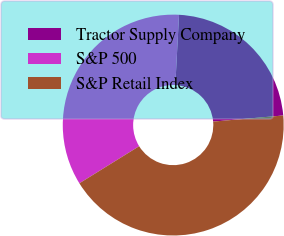Convert chart to OTSL. <chart><loc_0><loc_0><loc_500><loc_500><pie_chart><fcel>Tractor Supply Company<fcel>S&P 500<fcel>S&P Retail Index<nl><fcel>22.78%<fcel>34.68%<fcel>42.55%<nl></chart> 